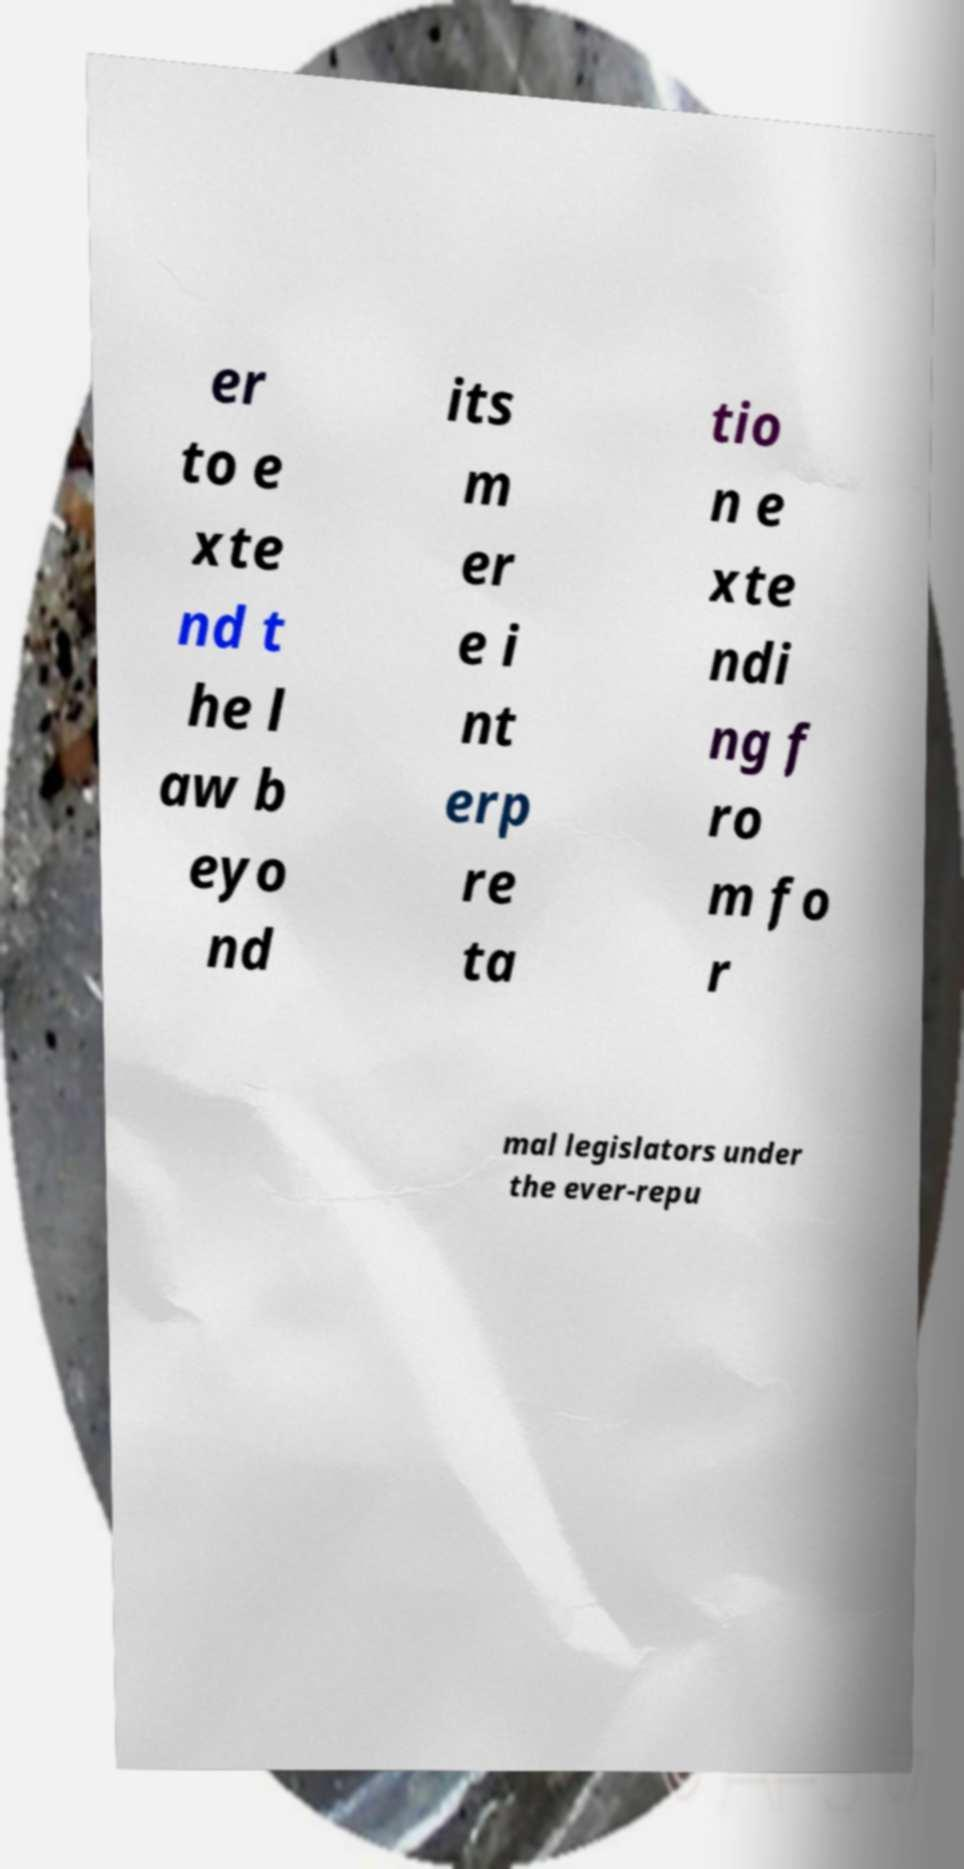What messages or text are displayed in this image? I need them in a readable, typed format. er to e xte nd t he l aw b eyo nd its m er e i nt erp re ta tio n e xte ndi ng f ro m fo r mal legislators under the ever-repu 